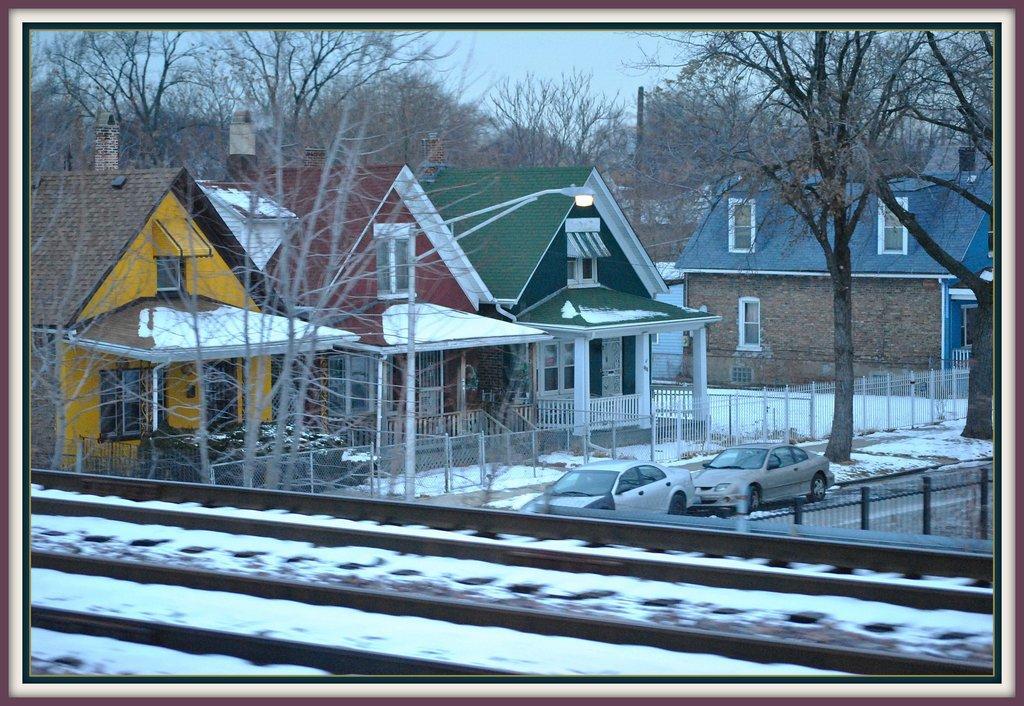Can you describe this image briefly? This is the picture of some houses and around there are some trees, cars snow and a train track to the side. 